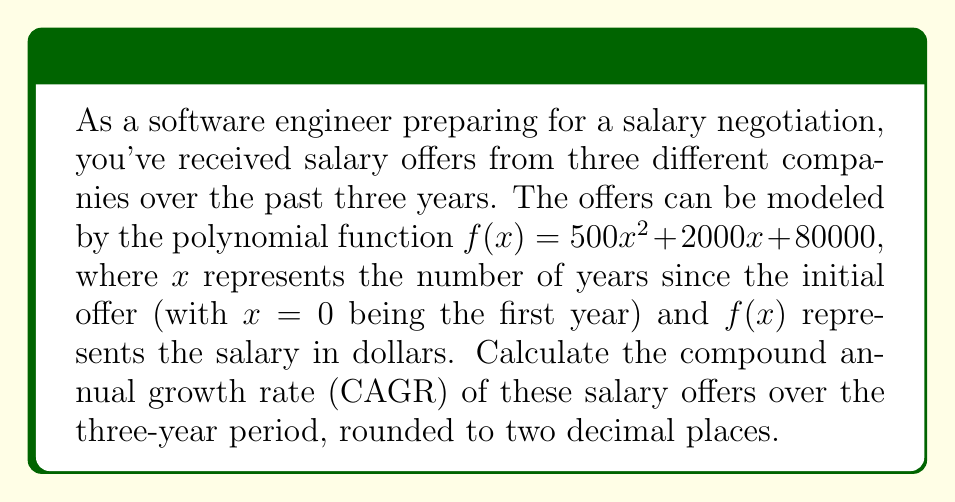Provide a solution to this math problem. To solve this problem, we'll follow these steps:

1. Calculate the initial salary and final salary using the given function.
2. Use the CAGR formula to determine the growth rate.

Step 1: Calculate initial and final salaries

Initial salary (Year 0): $f(0) = 500(0)^2 + 2000(0) + 80000 = $80,000$
Final salary (Year 2): $f(2) = 500(2)^2 + 2000(2) + 80000 = $88,000$

Step 2: Use the CAGR formula

The CAGR formula is:

$$ CAGR = \left(\frac{Ending Value}{Beginning Value}\right)^{\frac{1}{n}} - 1 $$

Where $n$ is the number of years.

Plugging in our values:

$$ CAGR = \left(\frac{88000}{80000}\right)^{\frac{1}{2}} - 1 $$

$$ CAGR = (1.1)^{0.5} - 1 $$

$$ CAGR = 1.0488 - 1 = 0.0488 $$

Convert to percentage: $0.0488 \times 100 = 4.88\%$

Rounded to two decimal places: $4.88\%$
Answer: The compound annual growth rate (CAGR) of the salary offers over the three-year period is 4.88%. 